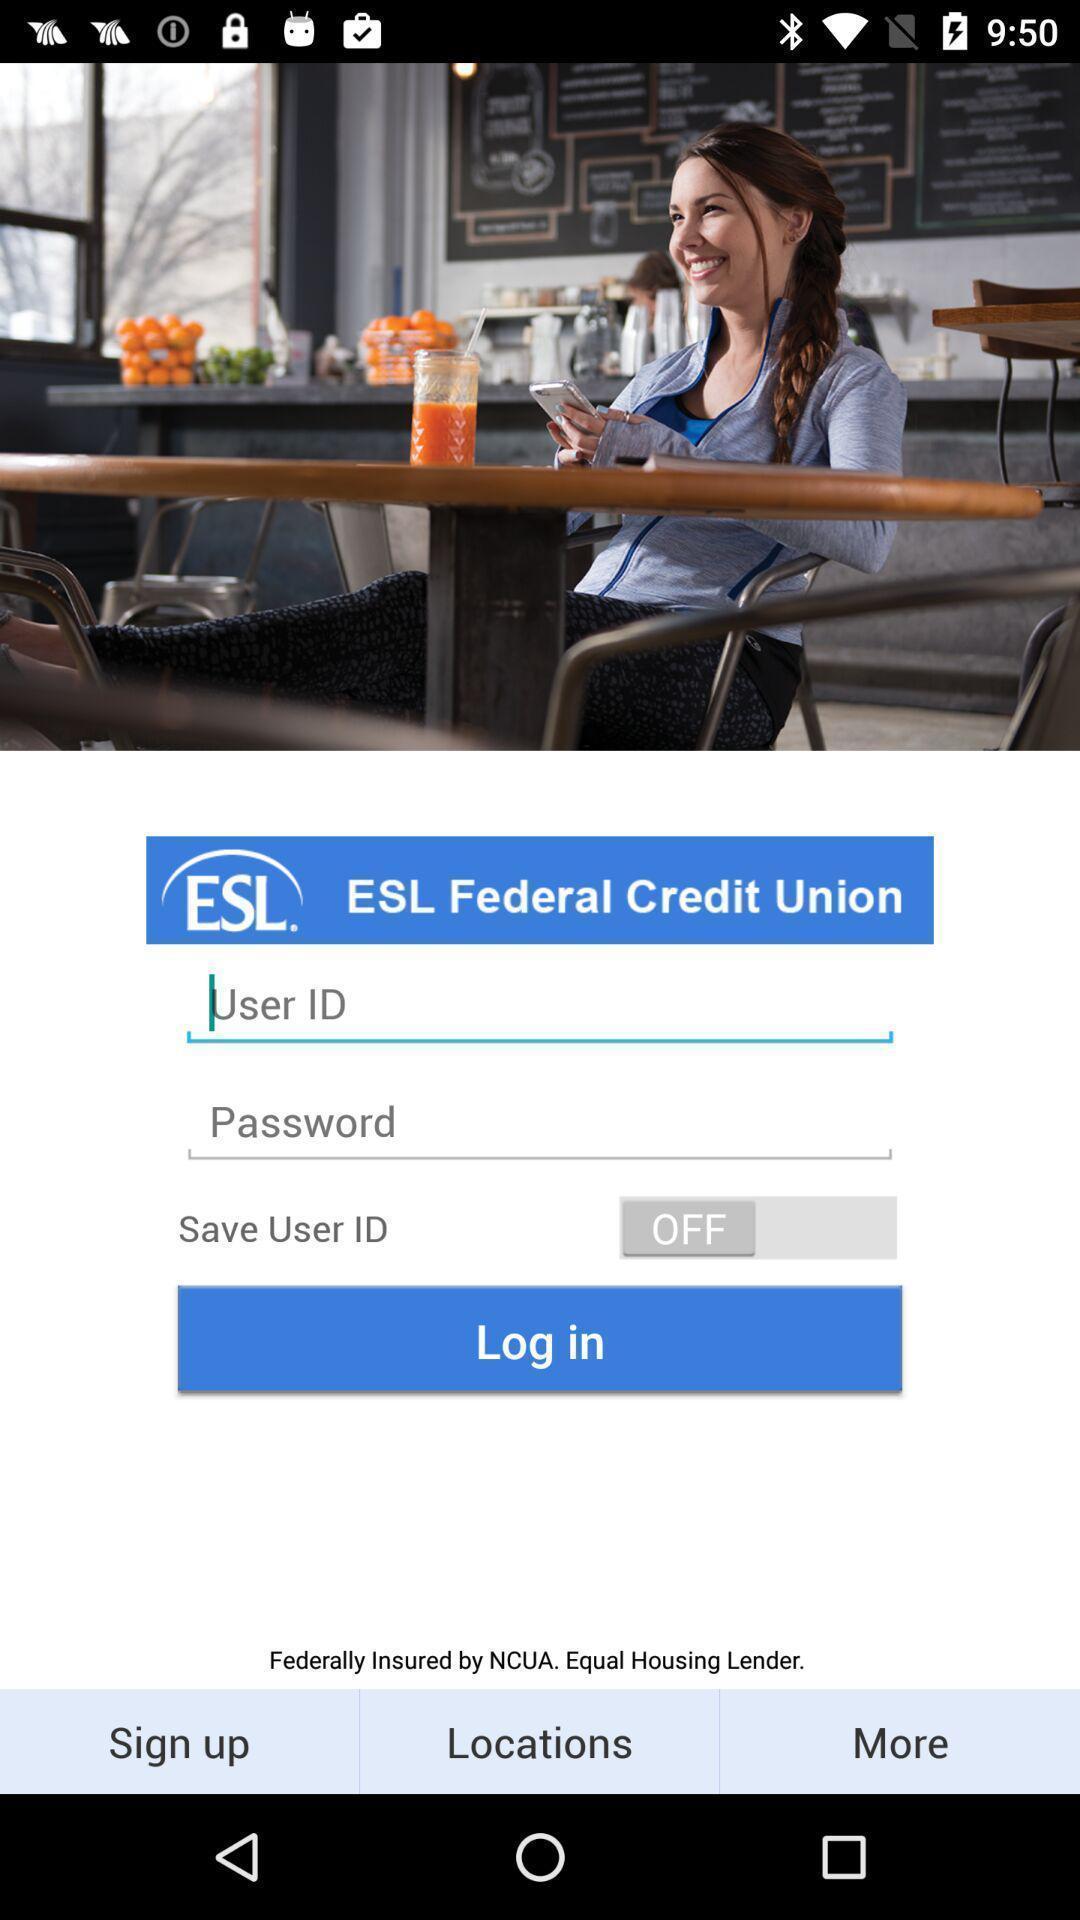Provide a description of this screenshot. Login page. 